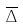<formula> <loc_0><loc_0><loc_500><loc_500>\overline { \Delta }</formula> 